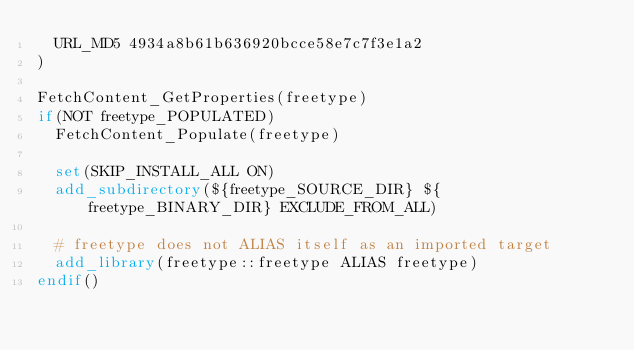<code> <loc_0><loc_0><loc_500><loc_500><_CMake_>  URL_MD5 4934a8b61b636920bcce58e7c7f3e1a2
)

FetchContent_GetProperties(freetype)
if(NOT freetype_POPULATED)
  FetchContent_Populate(freetype)

  set(SKIP_INSTALL_ALL ON)
  add_subdirectory(${freetype_SOURCE_DIR} ${freetype_BINARY_DIR} EXCLUDE_FROM_ALL)

  # freetype does not ALIAS itself as an imported target
  add_library(freetype::freetype ALIAS freetype)
endif()
</code> 